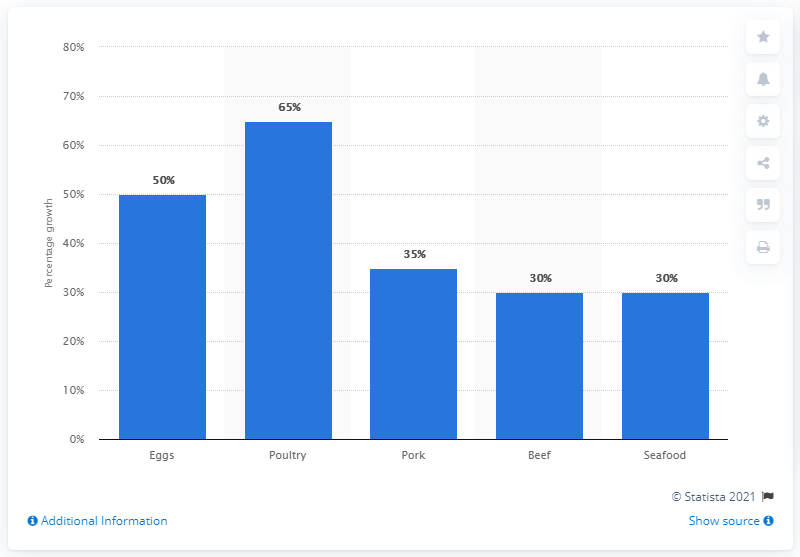Draw attention to some important aspects in this diagram. The global demand for eggs is predicted to grow by approximately 50% between 2015 and 2035. 